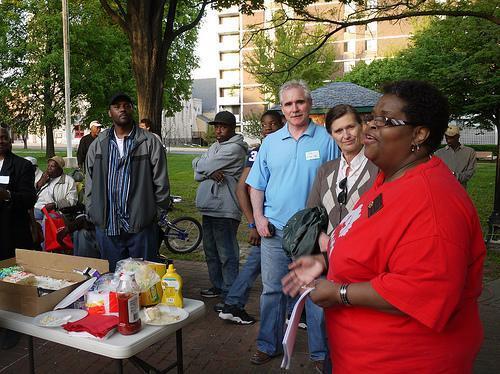How many colors on the glasses of the woman in orange?
Give a very brief answer. 2. How many people are in the photo?
Give a very brief answer. 12. 